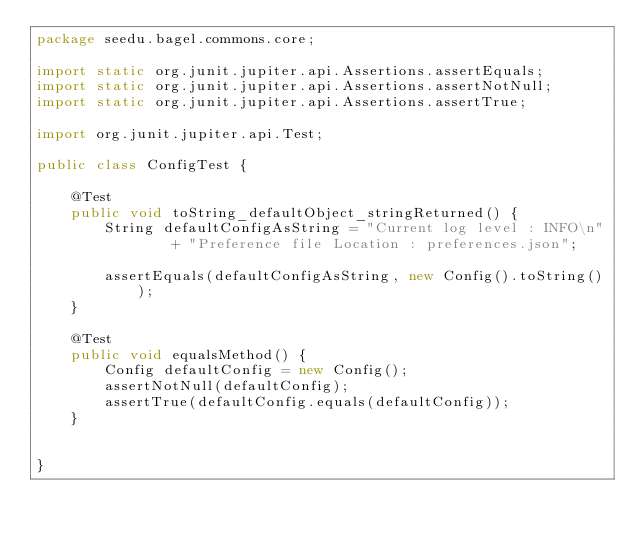Convert code to text. <code><loc_0><loc_0><loc_500><loc_500><_Java_>package seedu.bagel.commons.core;

import static org.junit.jupiter.api.Assertions.assertEquals;
import static org.junit.jupiter.api.Assertions.assertNotNull;
import static org.junit.jupiter.api.Assertions.assertTrue;

import org.junit.jupiter.api.Test;

public class ConfigTest {

    @Test
    public void toString_defaultObject_stringReturned() {
        String defaultConfigAsString = "Current log level : INFO\n"
                + "Preference file Location : preferences.json";

        assertEquals(defaultConfigAsString, new Config().toString());
    }

    @Test
    public void equalsMethod() {
        Config defaultConfig = new Config();
        assertNotNull(defaultConfig);
        assertTrue(defaultConfig.equals(defaultConfig));
    }


}
</code> 